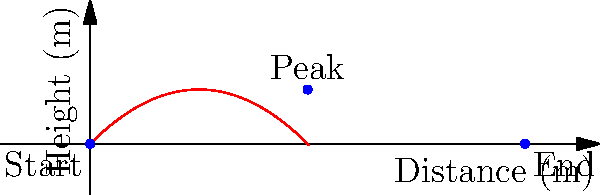During a telekinesis demonstration, an object is propelled with an initial velocity of 20 m/s at a 45-degree angle. Assuming no air resistance and normal Earth gravity, what is the maximum height reached by the object? To find the maximum height, we can follow these steps:

1) The vertical component of the initial velocity is:
   $v_{0y} = v_0 \sin(\theta) = 20 \sin(45°) = 20 \cdot \frac{\sqrt{2}}{2} \approx 14.14$ m/s

2) The time to reach the maximum height is when the vertical velocity becomes zero:
   $v_y = v_{0y} - gt = 0$
   $t = \frac{v_{0y}}{g} = \frac{14.14}{9.8} \approx 1.44$ seconds

3) The maximum height can be calculated using the equation:
   $h = v_{0y}t - \frac{1}{2}gt^2$

4) Substituting the values:
   $h = 14.14 \cdot 1.44 - \frac{1}{2} \cdot 9.8 \cdot 1.44^2$
   $h = 20.36 - 10.18 = 10.18$ meters

Therefore, the maximum height reached by the object is approximately 10.2 meters.
Answer: 10.2 meters 